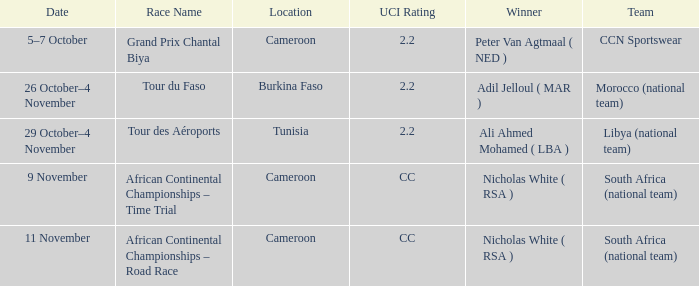Who is the winner of the race in Burkina Faso? Adil Jelloul ( MAR ). 